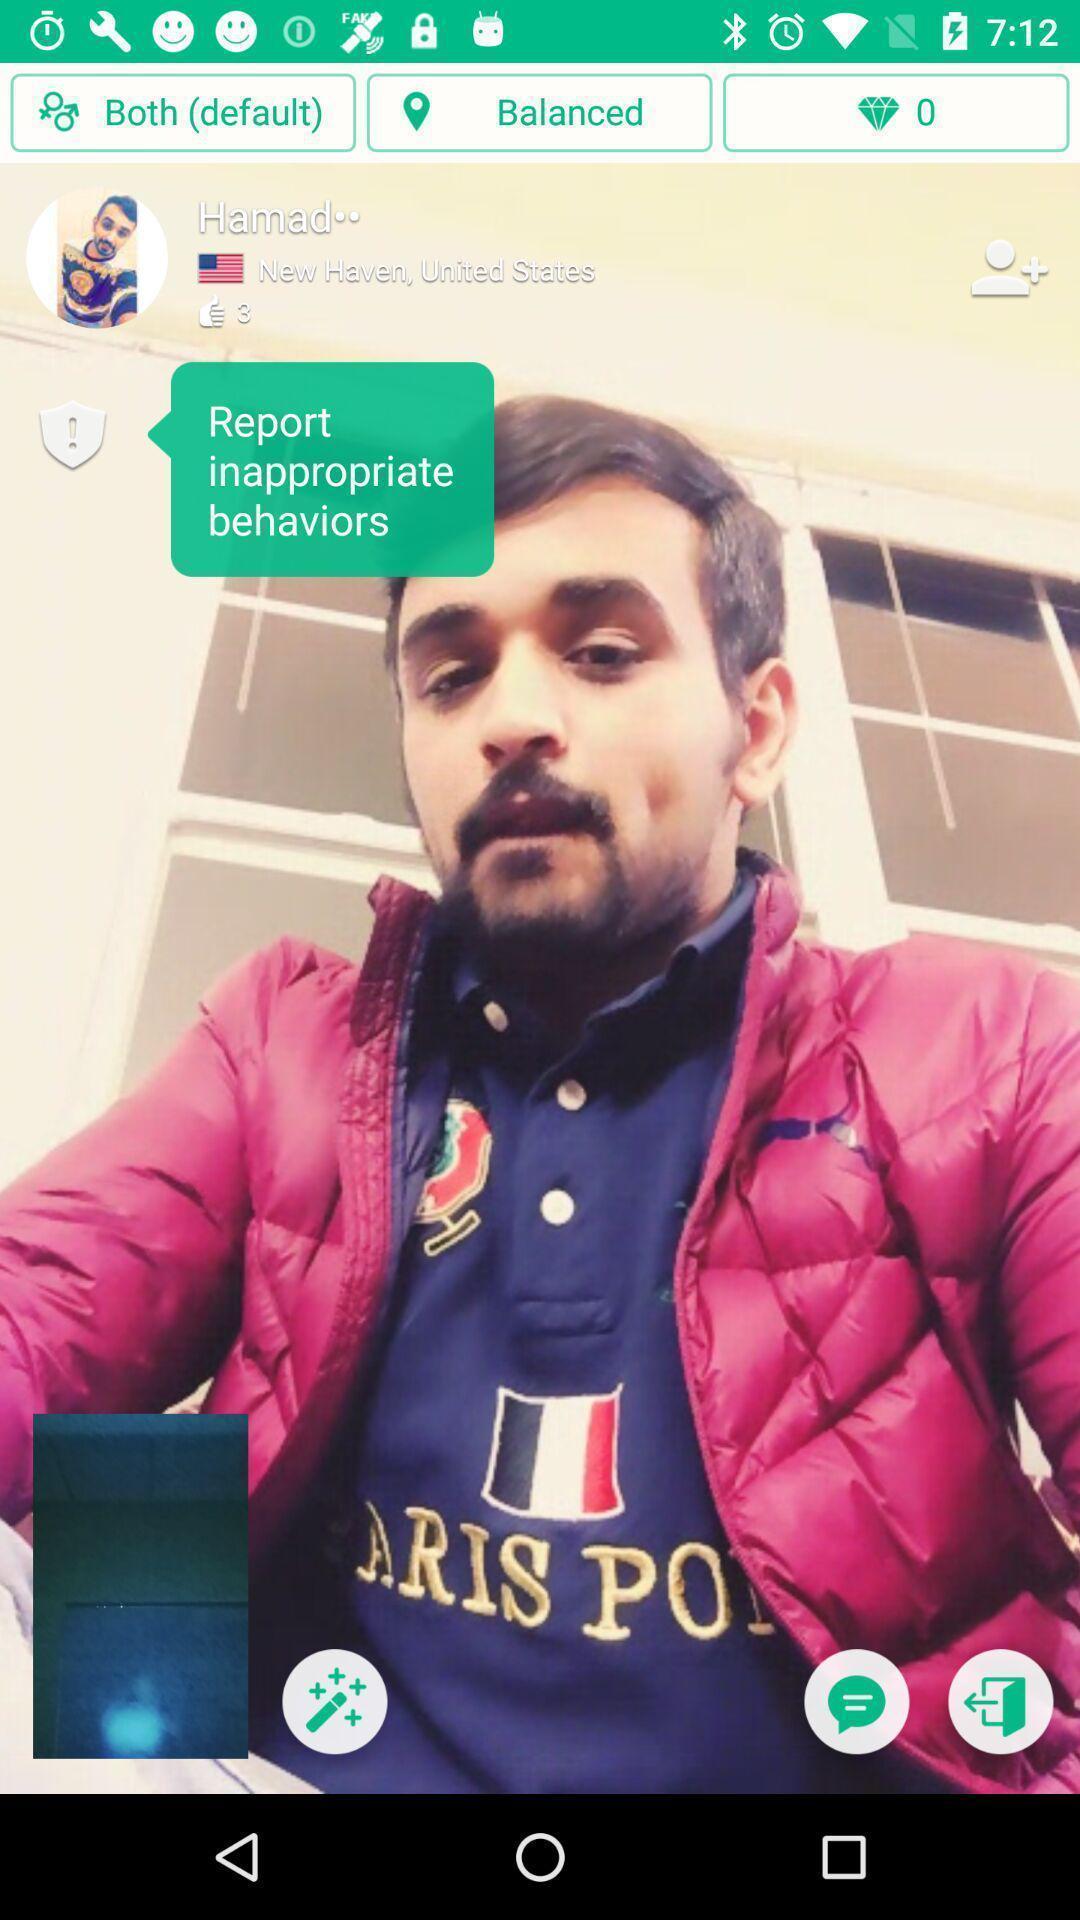Explain the elements present in this screenshot. Page showing different options on an app. 